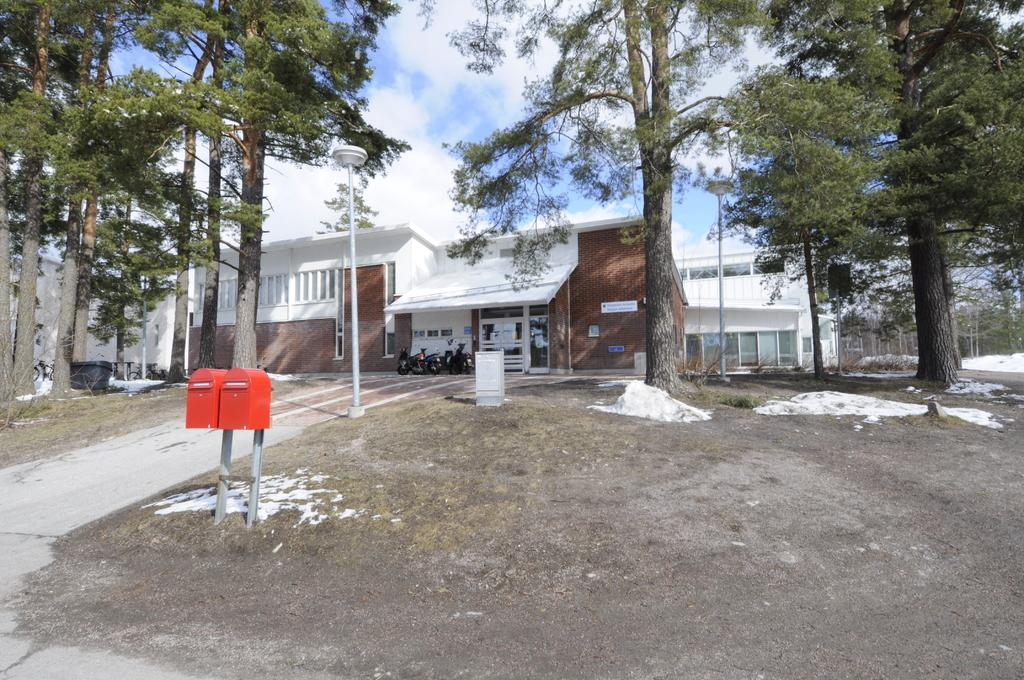What type of structures can be seen in the image? There are buildings in the image. What type of lighting is present in the image? There are pole lights in the image. What type of vegetation is present in the image? There are trees in the image. What type of infrastructure is present in the image? There are mailboxes in the image. What type of waste disposal container is present in the image? There is a dustbin on the ground in the image. How would you describe the sky in the image? The sky is blue and cloudy in the image. How many sisters are depicted in the image? There are no sisters present in the image. What type of approval is required for the mailboxes in the image? There is no mention of approval in the image; it simply shows the presence of mailboxes. Can you provide a receipt for the dustbin in the image? There is no need for a receipt for the dustbin in the image, as it is not a purchased item. 